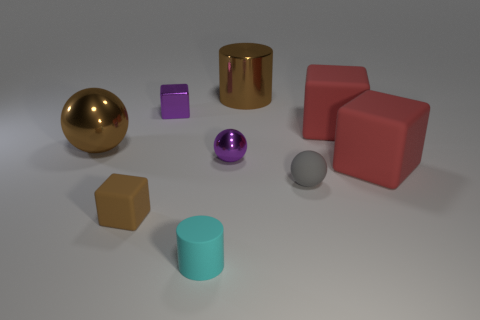Subtract all small brown rubber blocks. How many blocks are left? 3 Add 1 balls. How many objects exist? 10 Subtract 2 blocks. How many blocks are left? 2 Subtract all brown cubes. How many cubes are left? 3 Subtract all gray cylinders. How many red blocks are left? 2 Subtract all gray cylinders. Subtract all purple balls. How many cylinders are left? 2 Subtract all brown metal spheres. Subtract all brown shiny objects. How many objects are left? 6 Add 1 big things. How many big things are left? 5 Add 8 gray objects. How many gray objects exist? 9 Subtract 0 green balls. How many objects are left? 9 